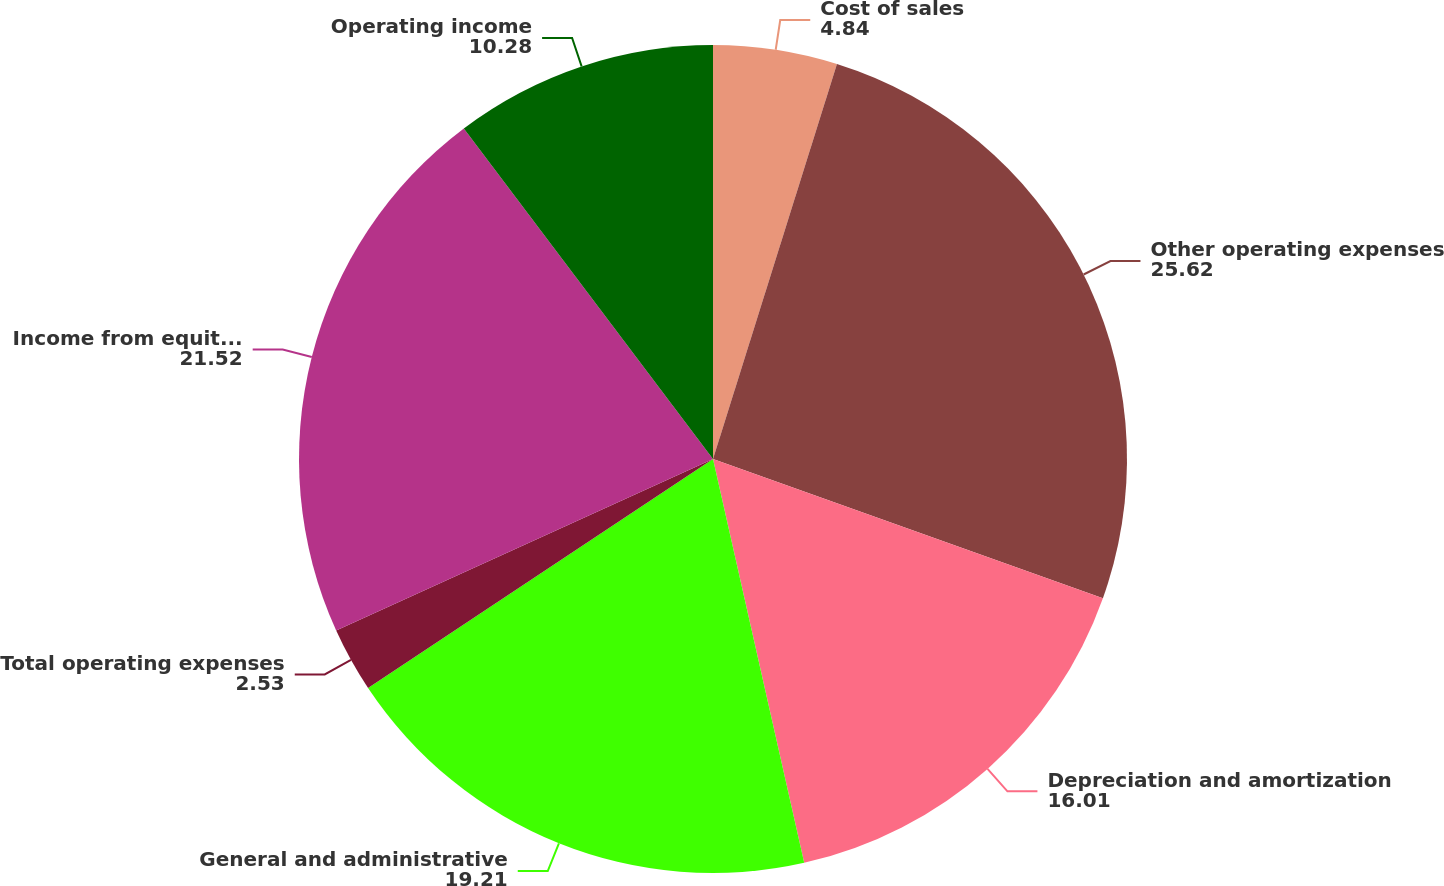Convert chart. <chart><loc_0><loc_0><loc_500><loc_500><pie_chart><fcel>Cost of sales<fcel>Other operating expenses<fcel>Depreciation and amortization<fcel>General and administrative<fcel>Total operating expenses<fcel>Income from equity investees<fcel>Operating income<nl><fcel>4.84%<fcel>25.62%<fcel>16.01%<fcel>19.21%<fcel>2.53%<fcel>21.52%<fcel>10.28%<nl></chart> 